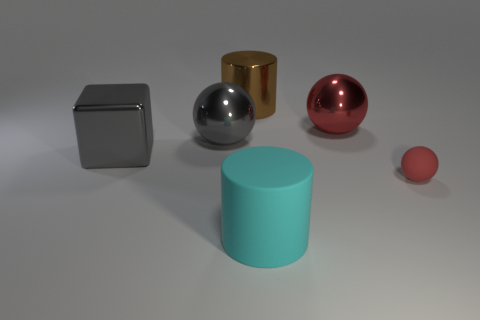Does the large metal thing that is right of the large brown metallic object have the same color as the tiny sphere?
Your answer should be very brief. Yes. Is the material of the big cube the same as the tiny thing?
Give a very brief answer. No. How many other things are there of the same material as the big brown object?
Provide a succinct answer. 3. There is another red object that is the same shape as the red matte object; what size is it?
Offer a terse response. Large. Are the big ball right of the big rubber cylinder and the cylinder that is behind the gray shiny cube made of the same material?
Ensure brevity in your answer.  Yes. Is the number of cyan cylinders that are on the left side of the big gray shiny block less than the number of large purple spheres?
Ensure brevity in your answer.  No. There is another metallic object that is the same shape as the cyan object; what is its color?
Give a very brief answer. Brown. There is a shiny ball that is on the right side of the brown cylinder; does it have the same size as the small ball?
Your answer should be very brief. No. How big is the ball that is to the left of the cylinder left of the cyan matte object?
Give a very brief answer. Large. Does the cyan object have the same material as the red object that is behind the rubber ball?
Your answer should be compact. No. 